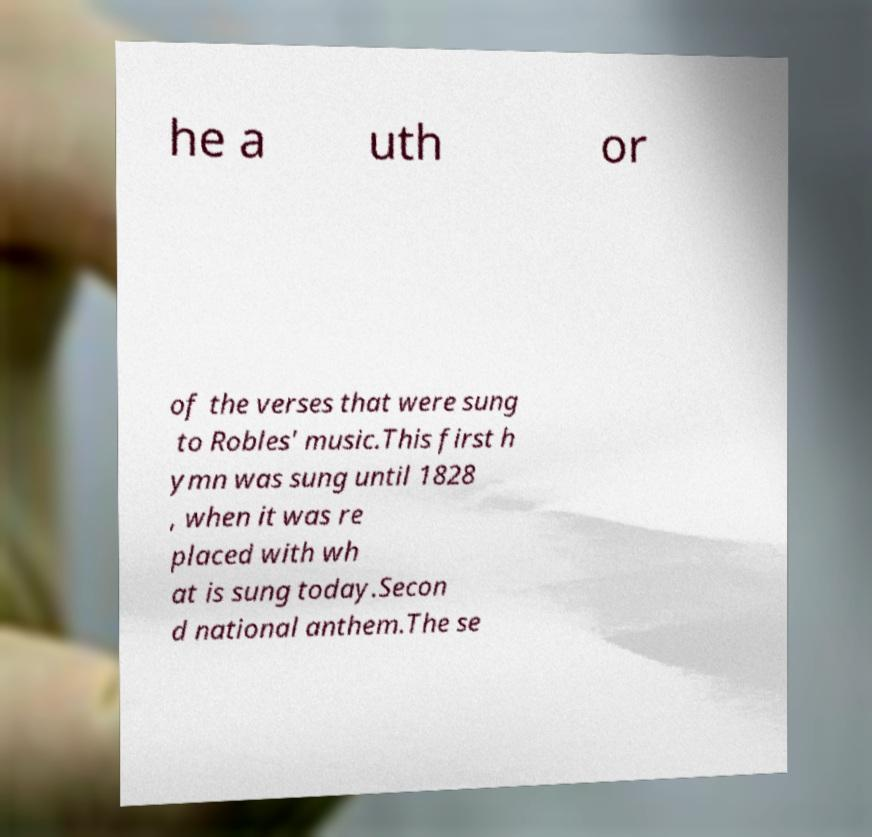I need the written content from this picture converted into text. Can you do that? he a uth or of the verses that were sung to Robles' music.This first h ymn was sung until 1828 , when it was re placed with wh at is sung today.Secon d national anthem.The se 